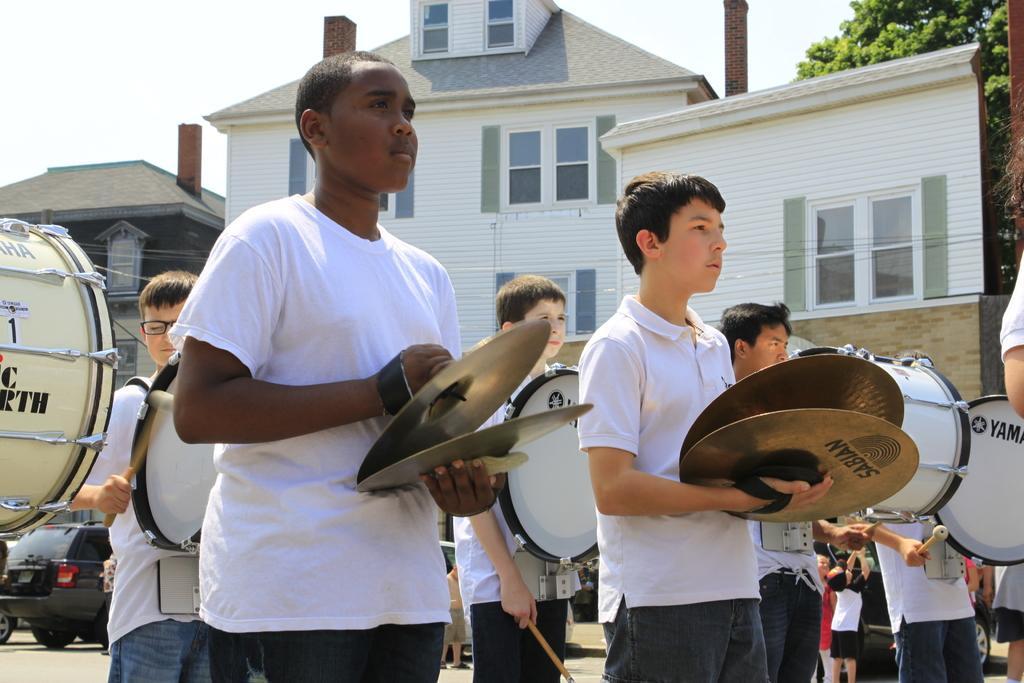Please provide a concise description of this image. This picture describes about group of people, few people are holding musical instruments, in the background we can see few vehicles, trees and buildings. 